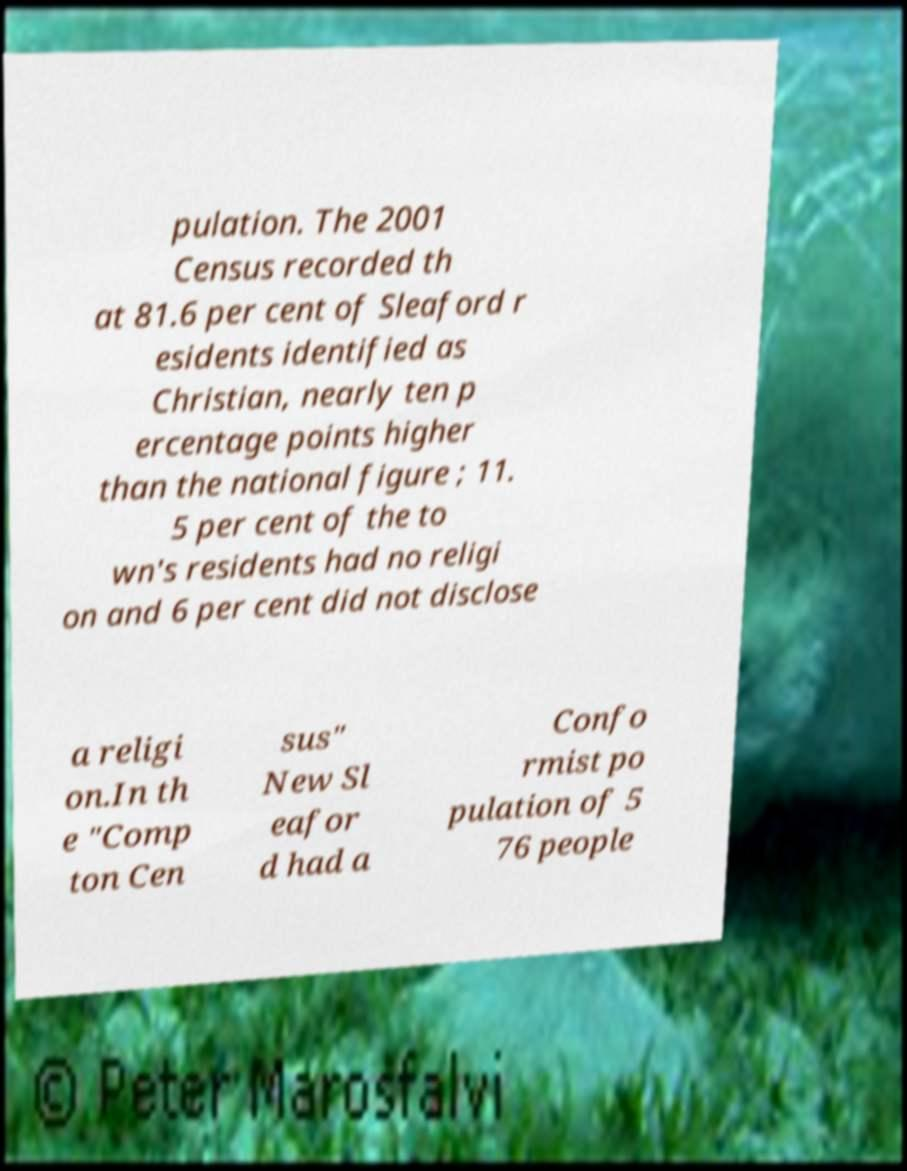For documentation purposes, I need the text within this image transcribed. Could you provide that? pulation. The 2001 Census recorded th at 81.6 per cent of Sleaford r esidents identified as Christian, nearly ten p ercentage points higher than the national figure ; 11. 5 per cent of the to wn's residents had no religi on and 6 per cent did not disclose a religi on.In th e "Comp ton Cen sus" New Sl eafor d had a Confo rmist po pulation of 5 76 people 